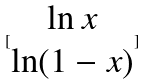Convert formula to latex. <formula><loc_0><loc_0><loc_500><loc_500>[ \begin{matrix} \ln x \\ \ln ( 1 - x ) \end{matrix} ]</formula> 